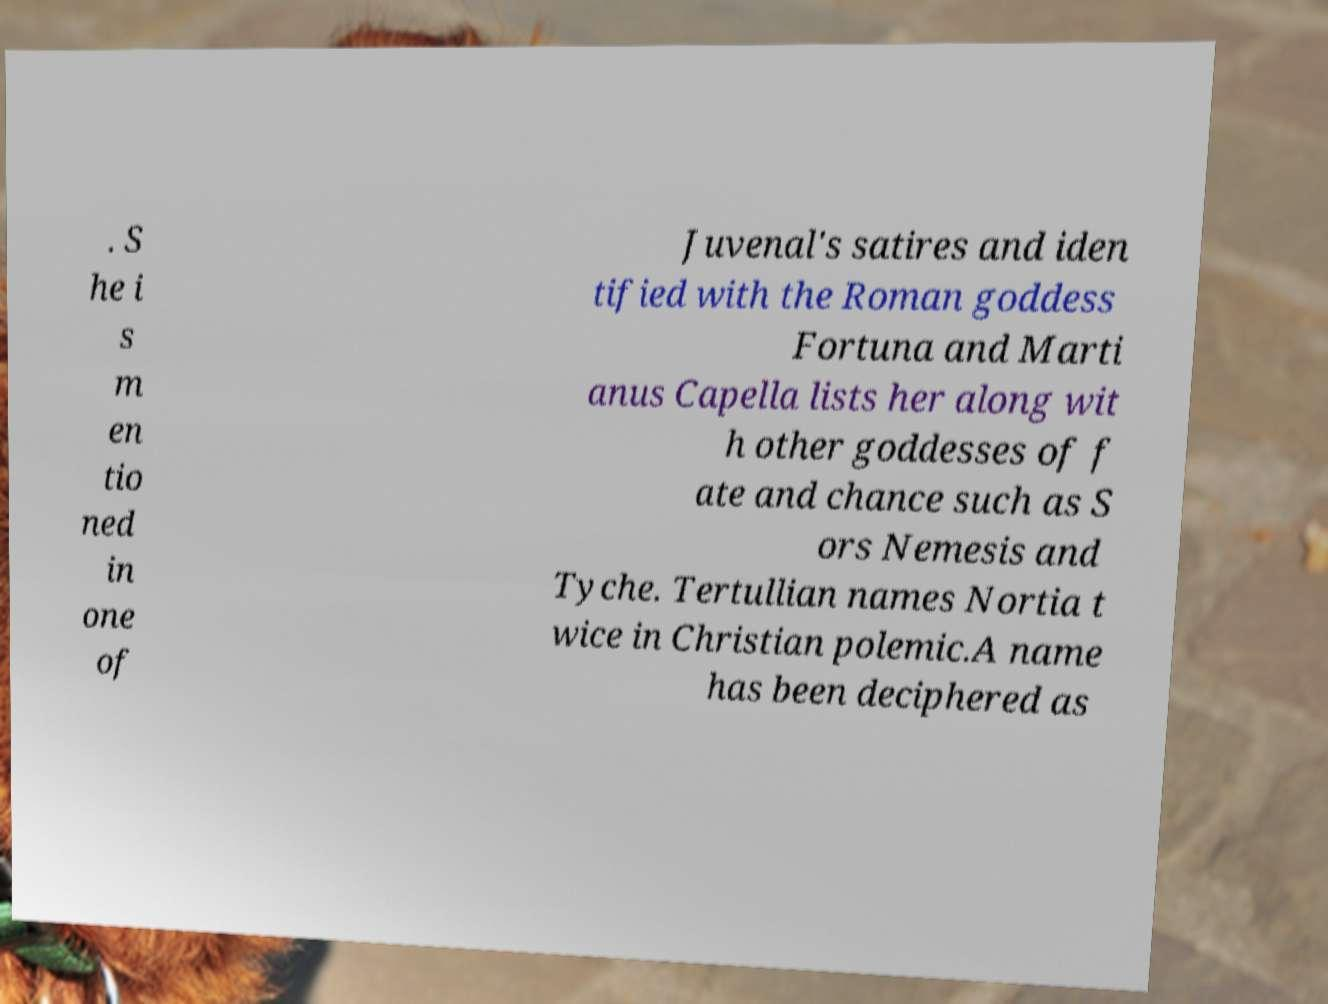For documentation purposes, I need the text within this image transcribed. Could you provide that? . S he i s m en tio ned in one of Juvenal's satires and iden tified with the Roman goddess Fortuna and Marti anus Capella lists her along wit h other goddesses of f ate and chance such as S ors Nemesis and Tyche. Tertullian names Nortia t wice in Christian polemic.A name has been deciphered as 